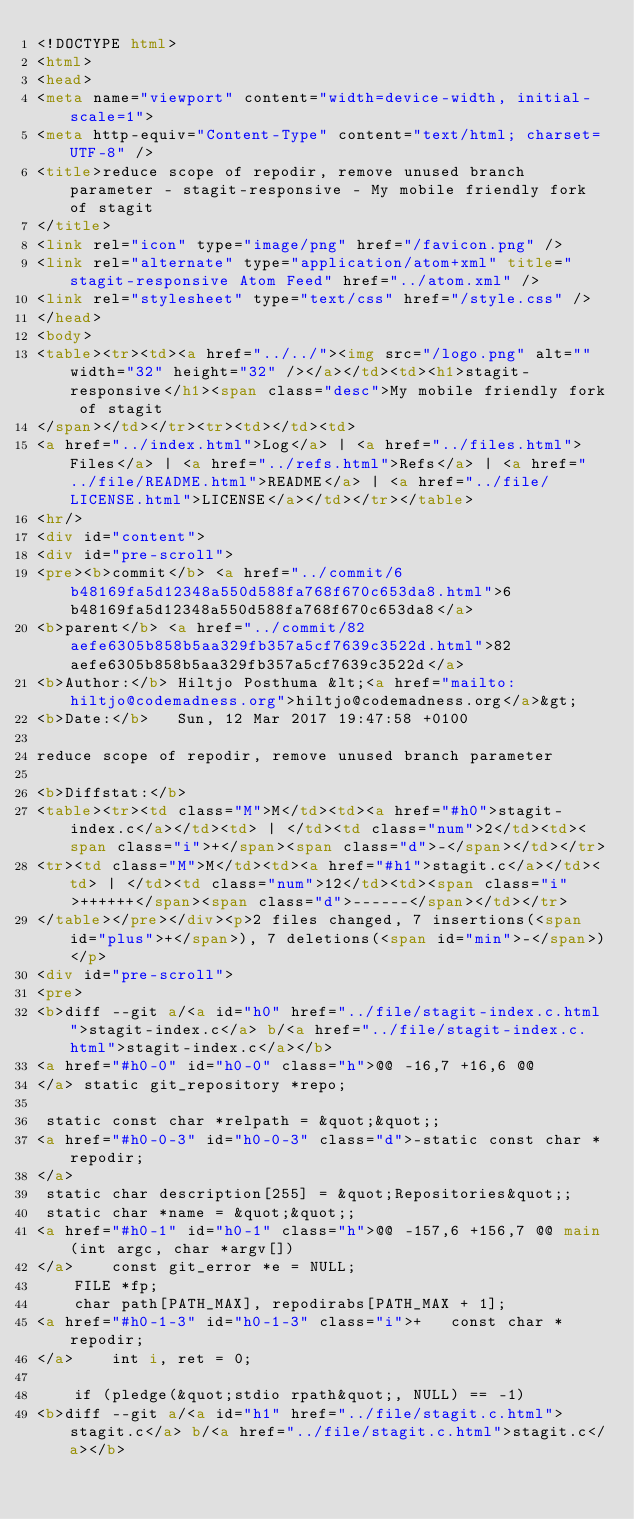Convert code to text. <code><loc_0><loc_0><loc_500><loc_500><_HTML_><!DOCTYPE html>
<html>
<head>
<meta name="viewport" content="width=device-width, initial-scale=1">
<meta http-equiv="Content-Type" content="text/html; charset=UTF-8" />
<title>reduce scope of repodir, remove unused branch parameter - stagit-responsive - My mobile friendly fork of stagit
</title>
<link rel="icon" type="image/png" href="/favicon.png" />
<link rel="alternate" type="application/atom+xml" title="stagit-responsive Atom Feed" href="../atom.xml" />
<link rel="stylesheet" type="text/css" href="/style.css" />
</head>
<body>
<table><tr><td><a href="../../"><img src="/logo.png" alt="" width="32" height="32" /></a></td><td><h1>stagit-responsive</h1><span class="desc">My mobile friendly fork of stagit
</span></td></tr><tr><td></td><td>
<a href="../index.html">Log</a> | <a href="../files.html">Files</a> | <a href="../refs.html">Refs</a> | <a href="../file/README.html">README</a> | <a href="../file/LICENSE.html">LICENSE</a></td></tr></table>
<hr/>
<div id="content">
<div id="pre-scroll">
<pre><b>commit</b> <a href="../commit/6b48169fa5d12348a550d588fa768f670c653da8.html">6b48169fa5d12348a550d588fa768f670c653da8</a>
<b>parent</b> <a href="../commit/82aefe6305b858b5aa329fb357a5cf7639c3522d.html">82aefe6305b858b5aa329fb357a5cf7639c3522d</a>
<b>Author:</b> Hiltjo Posthuma &lt;<a href="mailto:hiltjo@codemadness.org">hiltjo@codemadness.org</a>&gt;
<b>Date:</b>   Sun, 12 Mar 2017 19:47:58 +0100

reduce scope of repodir, remove unused branch parameter

<b>Diffstat:</b>
<table><tr><td class="M">M</td><td><a href="#h0">stagit-index.c</a></td><td> | </td><td class="num">2</td><td><span class="i">+</span><span class="d">-</span></td></tr>
<tr><td class="M">M</td><td><a href="#h1">stagit.c</a></td><td> | </td><td class="num">12</td><td><span class="i">++++++</span><span class="d">------</span></td></tr>
</table></pre></div><p>2 files changed, 7 insertions(<span id="plus">+</span>), 7 deletions(<span id="min">-</span>)</p>
<div id="pre-scroll">
<pre>
<b>diff --git a/<a id="h0" href="../file/stagit-index.c.html">stagit-index.c</a> b/<a href="../file/stagit-index.c.html">stagit-index.c</a></b>
<a href="#h0-0" id="h0-0" class="h">@@ -16,7 +16,6 @@
</a> static git_repository *repo;
 
 static const char *relpath = &quot;&quot;;
<a href="#h0-0-3" id="h0-0-3" class="d">-static const char *repodir;
</a> 
 static char description[255] = &quot;Repositories&quot;;
 static char *name = &quot;&quot;;
<a href="#h0-1" id="h0-1" class="h">@@ -157,6 +156,7 @@ main(int argc, char *argv[])
</a> 	const git_error *e = NULL;
 	FILE *fp;
 	char path[PATH_MAX], repodirabs[PATH_MAX + 1];
<a href="#h0-1-3" id="h0-1-3" class="i">+	const char *repodir;
</a> 	int i, ret = 0;
 
 	if (pledge(&quot;stdio rpath&quot;, NULL) == -1)
<b>diff --git a/<a id="h1" href="../file/stagit.c.html">stagit.c</a> b/<a href="../file/stagit.c.html">stagit.c</a></b></code> 